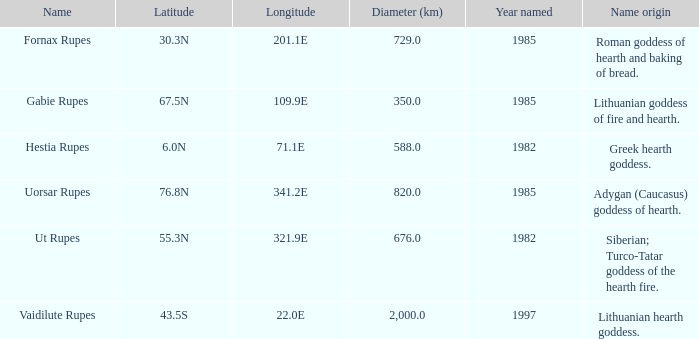What was the diameter of the feature found in 1997? 2000.0. 